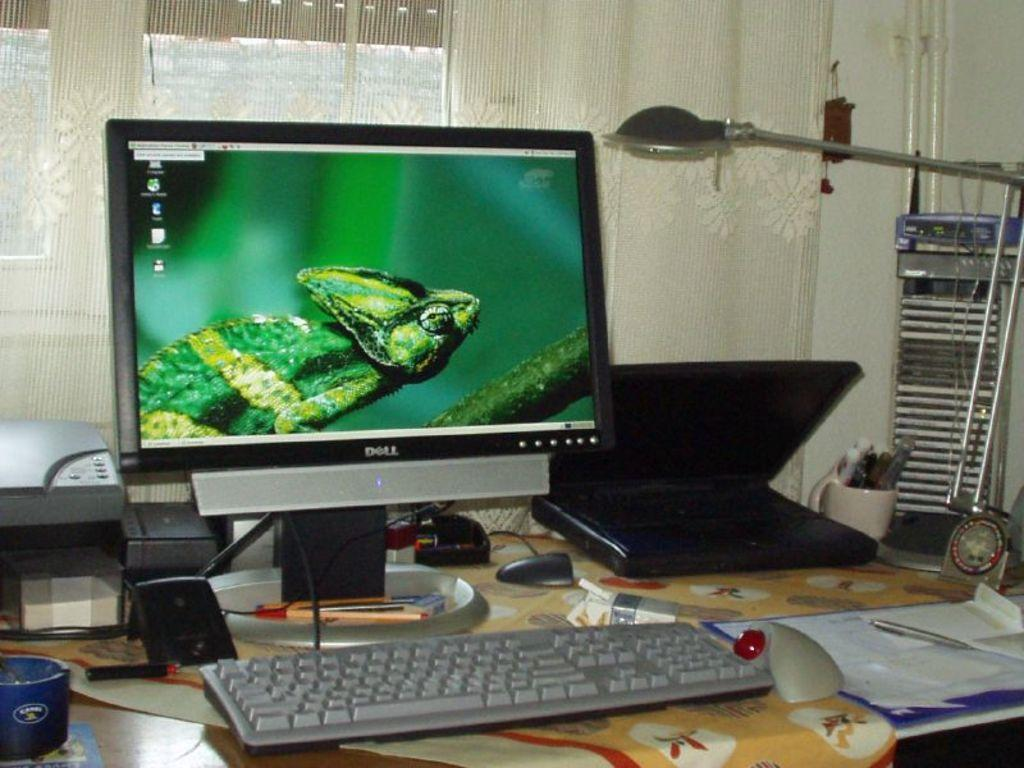<image>
Summarize the visual content of the image. A chameleon fills the screen of a Dell computer monitor. 